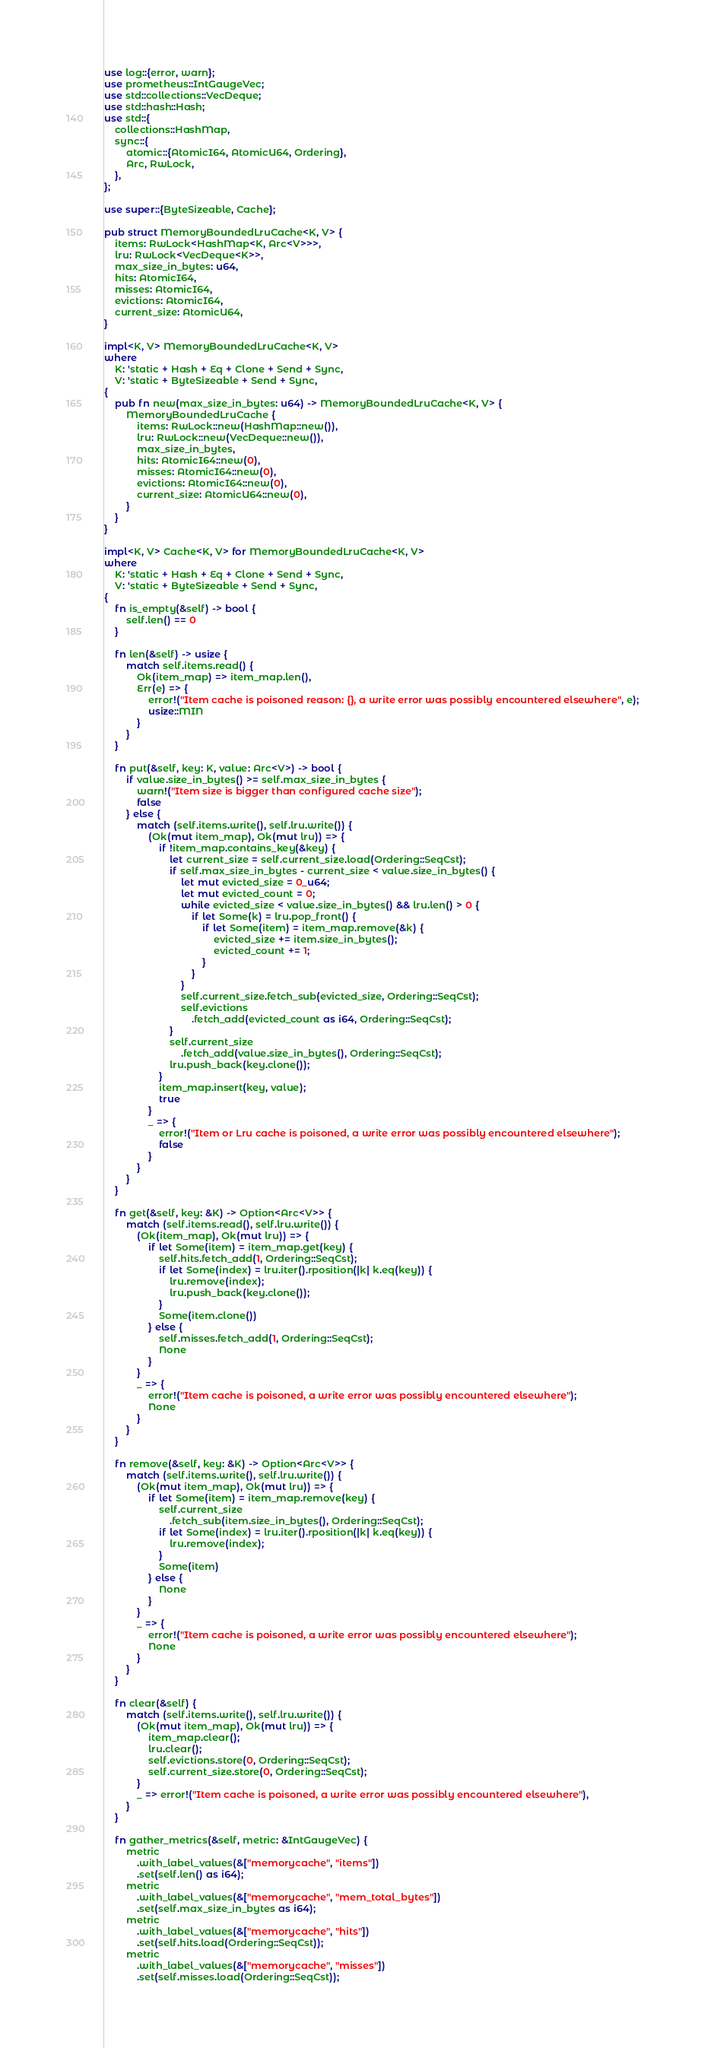<code> <loc_0><loc_0><loc_500><loc_500><_Rust_>use log::{error, warn};
use prometheus::IntGaugeVec;
use std::collections::VecDeque;
use std::hash::Hash;
use std::{
    collections::HashMap,
    sync::{
        atomic::{AtomicI64, AtomicU64, Ordering},
        Arc, RwLock,
    },
};

use super::{ByteSizeable, Cache};

pub struct MemoryBoundedLruCache<K, V> {
    items: RwLock<HashMap<K, Arc<V>>>,
    lru: RwLock<VecDeque<K>>,
    max_size_in_bytes: u64,
    hits: AtomicI64,
    misses: AtomicI64,
    evictions: AtomicI64,
    current_size: AtomicU64,
}

impl<K, V> MemoryBoundedLruCache<K, V>
where
    K: 'static + Hash + Eq + Clone + Send + Sync,
    V: 'static + ByteSizeable + Send + Sync,
{
    pub fn new(max_size_in_bytes: u64) -> MemoryBoundedLruCache<K, V> {
        MemoryBoundedLruCache {
            items: RwLock::new(HashMap::new()),
            lru: RwLock::new(VecDeque::new()),
            max_size_in_bytes,
            hits: AtomicI64::new(0),
            misses: AtomicI64::new(0),
            evictions: AtomicI64::new(0),
            current_size: AtomicU64::new(0),
        }
    }
}

impl<K, V> Cache<K, V> for MemoryBoundedLruCache<K, V>
where
    K: 'static + Hash + Eq + Clone + Send + Sync,
    V: 'static + ByteSizeable + Send + Sync,
{
    fn is_empty(&self) -> bool {
        self.len() == 0
    }

    fn len(&self) -> usize {
        match self.items.read() {
            Ok(item_map) => item_map.len(),
            Err(e) => {
                error!("Item cache is poisoned reason: {}, a write error was possibly encountered elsewhere", e);
                usize::MIN
            }
        }
    }

    fn put(&self, key: K, value: Arc<V>) -> bool {
        if value.size_in_bytes() >= self.max_size_in_bytes {
            warn!("Item size is bigger than configured cache size");
            false
        } else {
            match (self.items.write(), self.lru.write()) {
                (Ok(mut item_map), Ok(mut lru)) => {
                    if !item_map.contains_key(&key) {
                        let current_size = self.current_size.load(Ordering::SeqCst);
                        if self.max_size_in_bytes - current_size < value.size_in_bytes() {
                            let mut evicted_size = 0_u64;
                            let mut evicted_count = 0;
                            while evicted_size < value.size_in_bytes() && lru.len() > 0 {
                                if let Some(k) = lru.pop_front() {
                                    if let Some(item) = item_map.remove(&k) {
                                        evicted_size += item.size_in_bytes();
                                        evicted_count += 1;
                                    }
                                }
                            }
                            self.current_size.fetch_sub(evicted_size, Ordering::SeqCst);
                            self.evictions
                                .fetch_add(evicted_count as i64, Ordering::SeqCst);
                        }
                        self.current_size
                            .fetch_add(value.size_in_bytes(), Ordering::SeqCst);
                        lru.push_back(key.clone());
                    }
                    item_map.insert(key, value);
                    true
                }
                _ => {
                    error!("Item or Lru cache is poisoned, a write error was possibly encountered elsewhere");
                    false
                }
            }
        }
    }

    fn get(&self, key: &K) -> Option<Arc<V>> {
        match (self.items.read(), self.lru.write()) {
            (Ok(item_map), Ok(mut lru)) => {
                if let Some(item) = item_map.get(key) {
                    self.hits.fetch_add(1, Ordering::SeqCst);
                    if let Some(index) = lru.iter().rposition(|k| k.eq(key)) {
                        lru.remove(index);
                        lru.push_back(key.clone());
                    }
                    Some(item.clone())
                } else {
                    self.misses.fetch_add(1, Ordering::SeqCst);
                    None
                }
            }
            _ => {
                error!("Item cache is poisoned, a write error was possibly encountered elsewhere");
                None
            }
        }
    }

    fn remove(&self, key: &K) -> Option<Arc<V>> {
        match (self.items.write(), self.lru.write()) {
            (Ok(mut item_map), Ok(mut lru)) => {
                if let Some(item) = item_map.remove(key) {
                    self.current_size
                        .fetch_sub(item.size_in_bytes(), Ordering::SeqCst);
                    if let Some(index) = lru.iter().rposition(|k| k.eq(key)) {
                        lru.remove(index);
                    }
                    Some(item)
                } else {
                    None
                }
            }
            _ => {
                error!("Item cache is poisoned, a write error was possibly encountered elsewhere");
                None
            }
        }
    }

    fn clear(&self) {
        match (self.items.write(), self.lru.write()) {
            (Ok(mut item_map), Ok(mut lru)) => {
                item_map.clear();
                lru.clear();
                self.evictions.store(0, Ordering::SeqCst);
                self.current_size.store(0, Ordering::SeqCst);
            }
            _ => error!("Item cache is poisoned, a write error was possibly encountered elsewhere"),
        }
    }

    fn gather_metrics(&self, metric: &IntGaugeVec) {
        metric
            .with_label_values(&["memorycache", "items"])
            .set(self.len() as i64);
        metric
            .with_label_values(&["memorycache", "mem_total_bytes"])
            .set(self.max_size_in_bytes as i64);
        metric
            .with_label_values(&["memorycache", "hits"])
            .set(self.hits.load(Ordering::SeqCst));
        metric
            .with_label_values(&["memorycache", "misses"])
            .set(self.misses.load(Ordering::SeqCst));</code> 